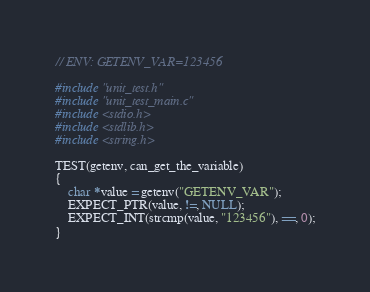<code> <loc_0><loc_0><loc_500><loc_500><_C_>// ENV: GETENV_VAR=123456

#include "unit_test.h"
#include "unit_test_main.c"
#include <stdio.h>
#include <stdlib.h>
#include <string.h>

TEST(getenv, can_get_the_variable)
{
    char *value = getenv("GETENV_VAR");
    EXPECT_PTR(value, !=, NULL);
    EXPECT_INT(strcmp(value, "123456"), ==, 0);
}
</code> 